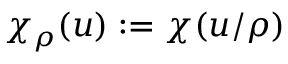<formula> <loc_0><loc_0><loc_500><loc_500>\chi _ { \rho } ( u ) \colon = \chi ( u / \rho )</formula> 